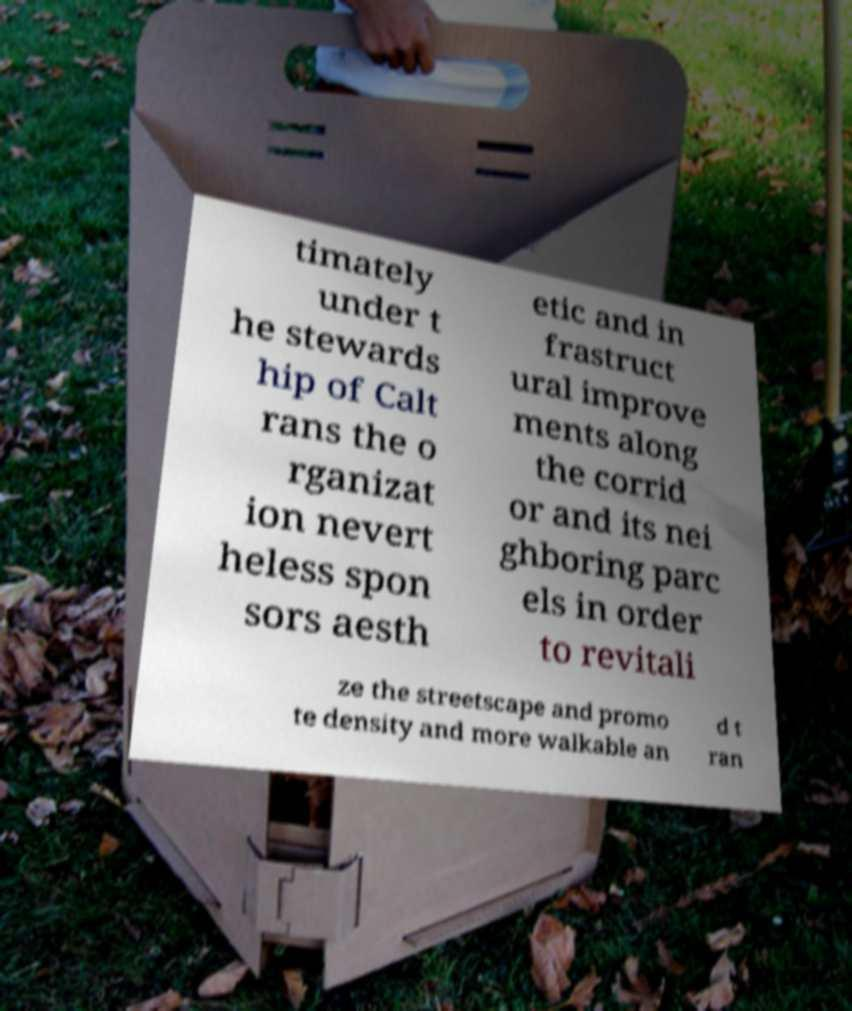For documentation purposes, I need the text within this image transcribed. Could you provide that? timately under t he stewards hip of Calt rans the o rganizat ion nevert heless spon sors aesth etic and in frastruct ural improve ments along the corrid or and its nei ghboring parc els in order to revitali ze the streetscape and promo te density and more walkable an d t ran 